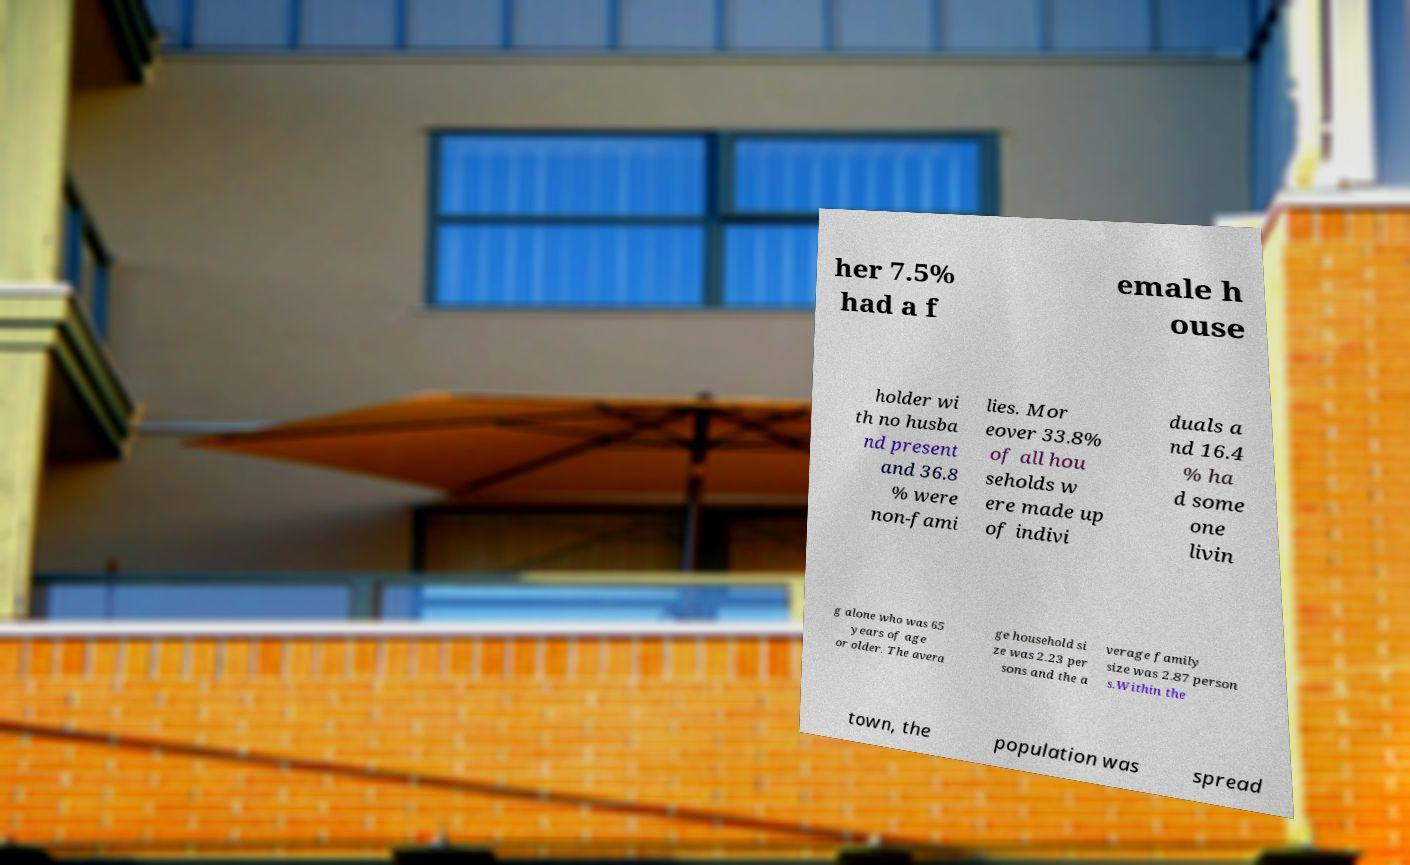There's text embedded in this image that I need extracted. Can you transcribe it verbatim? her 7.5% had a f emale h ouse holder wi th no husba nd present and 36.8 % were non-fami lies. Mor eover 33.8% of all hou seholds w ere made up of indivi duals a nd 16.4 % ha d some one livin g alone who was 65 years of age or older. The avera ge household si ze was 2.23 per sons and the a verage family size was 2.87 person s.Within the town, the population was spread 